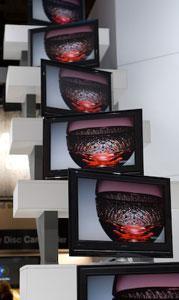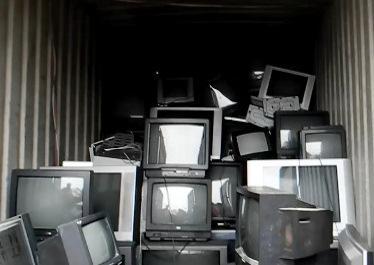The first image is the image on the left, the second image is the image on the right. Analyze the images presented: Is the assertion "Each image shows stacks of different model old-fashioned TV sets, and the right image includes some TVs with static on the screens." valid? Answer yes or no. No. 